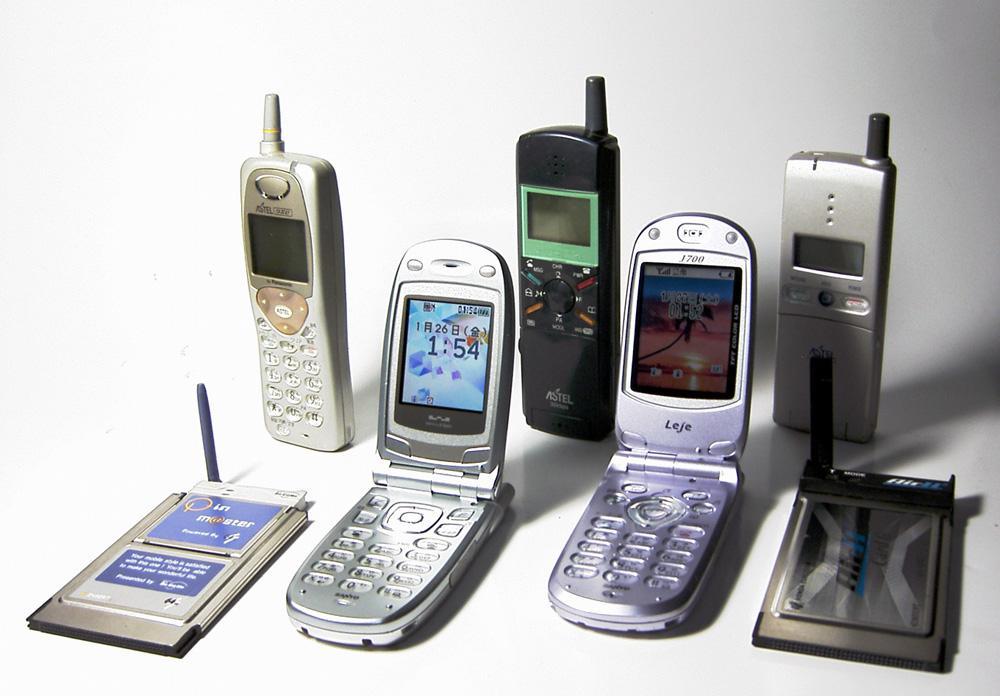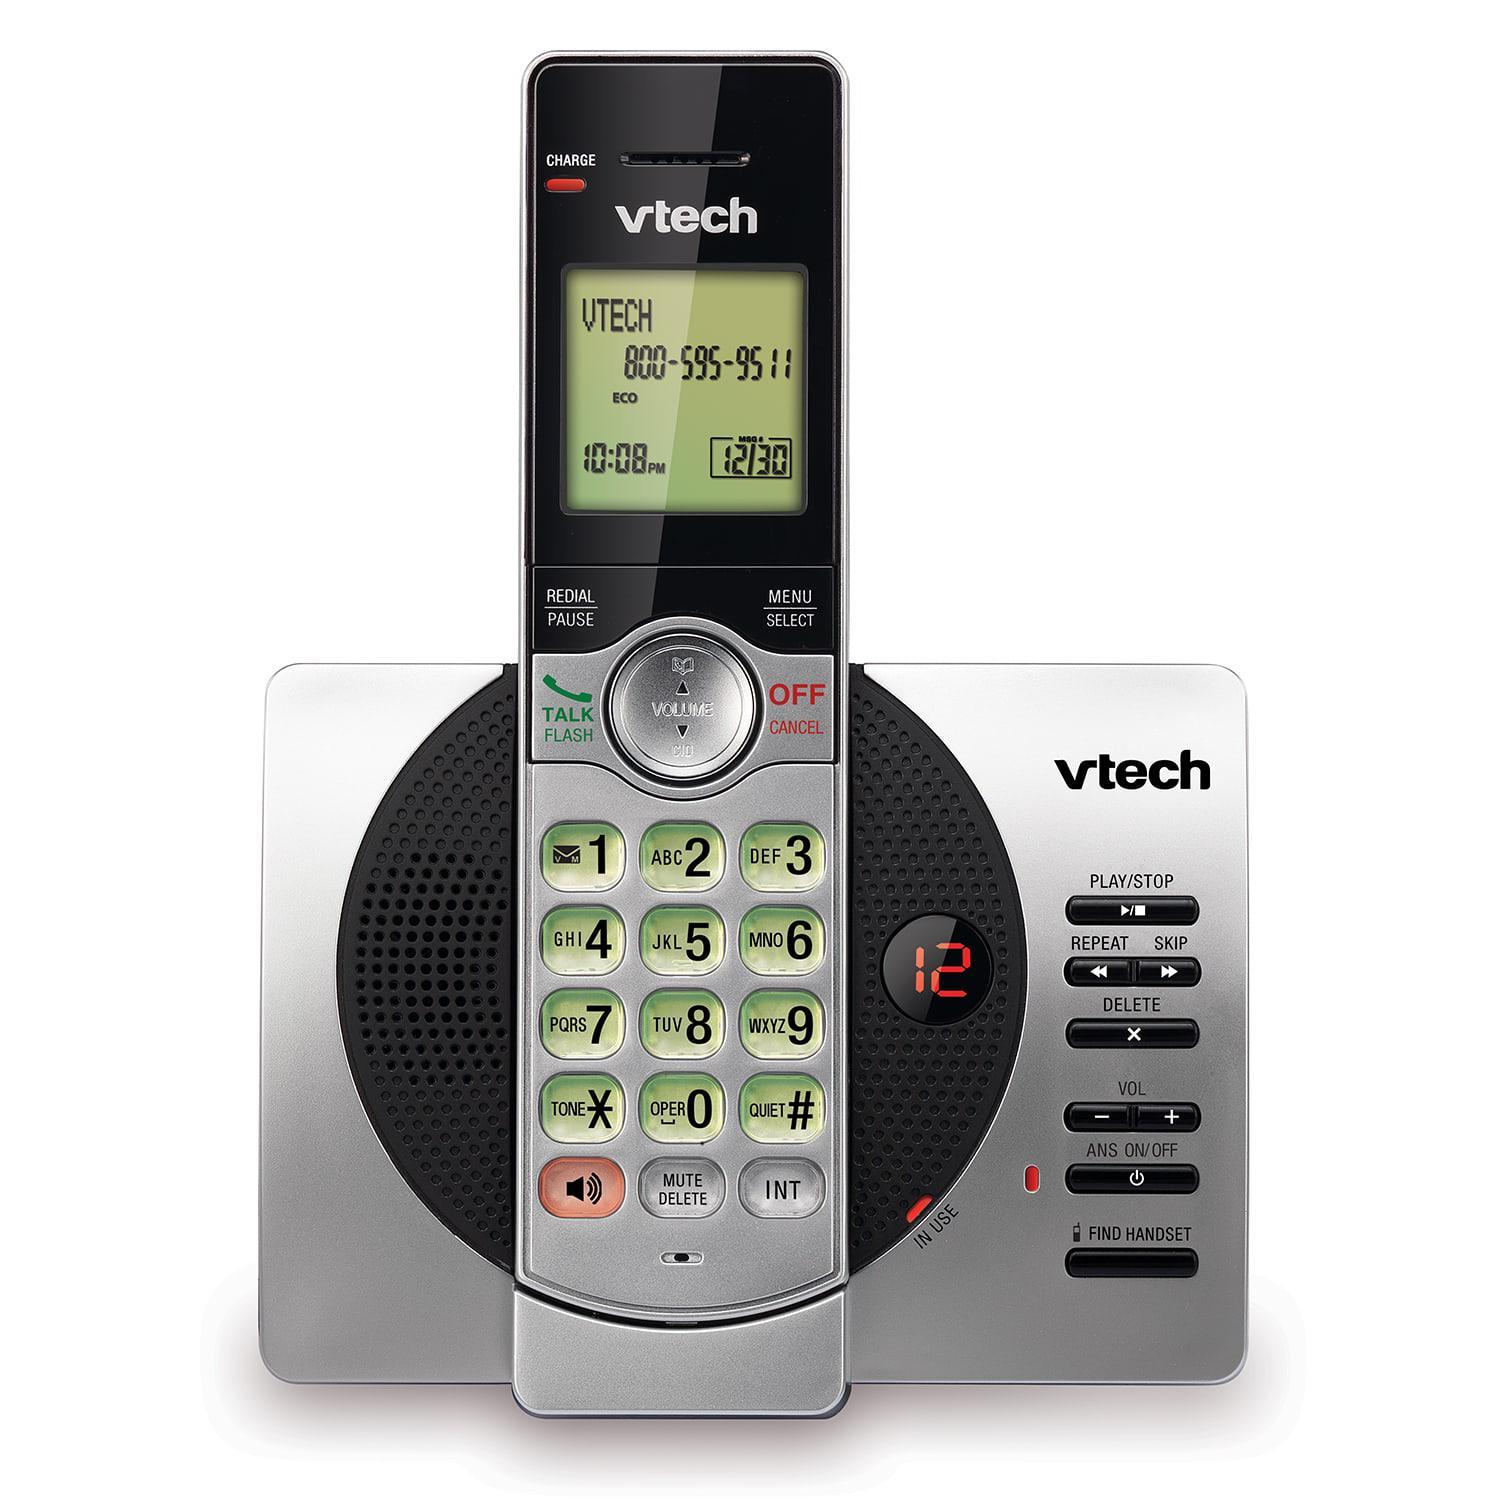The first image is the image on the left, the second image is the image on the right. For the images shown, is this caption "The combined images include two handsets that rest in silver stands and have a bright blue square screen on black." true? Answer yes or no. No. The first image is the image on the left, the second image is the image on the right. Evaluate the accuracy of this statement regarding the images: "There are less than 4 phones.". Is it true? Answer yes or no. No. 